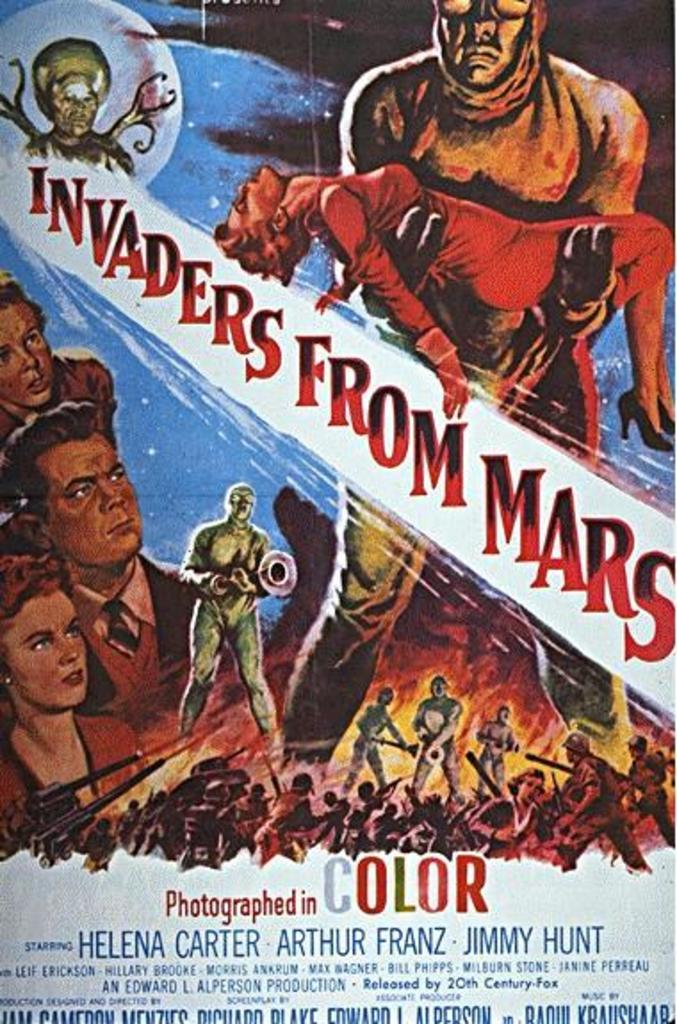<image>
Provide a brief description of the given image. A movie poster in color of the movie Invaders From Mars with images of aliens and humans. 